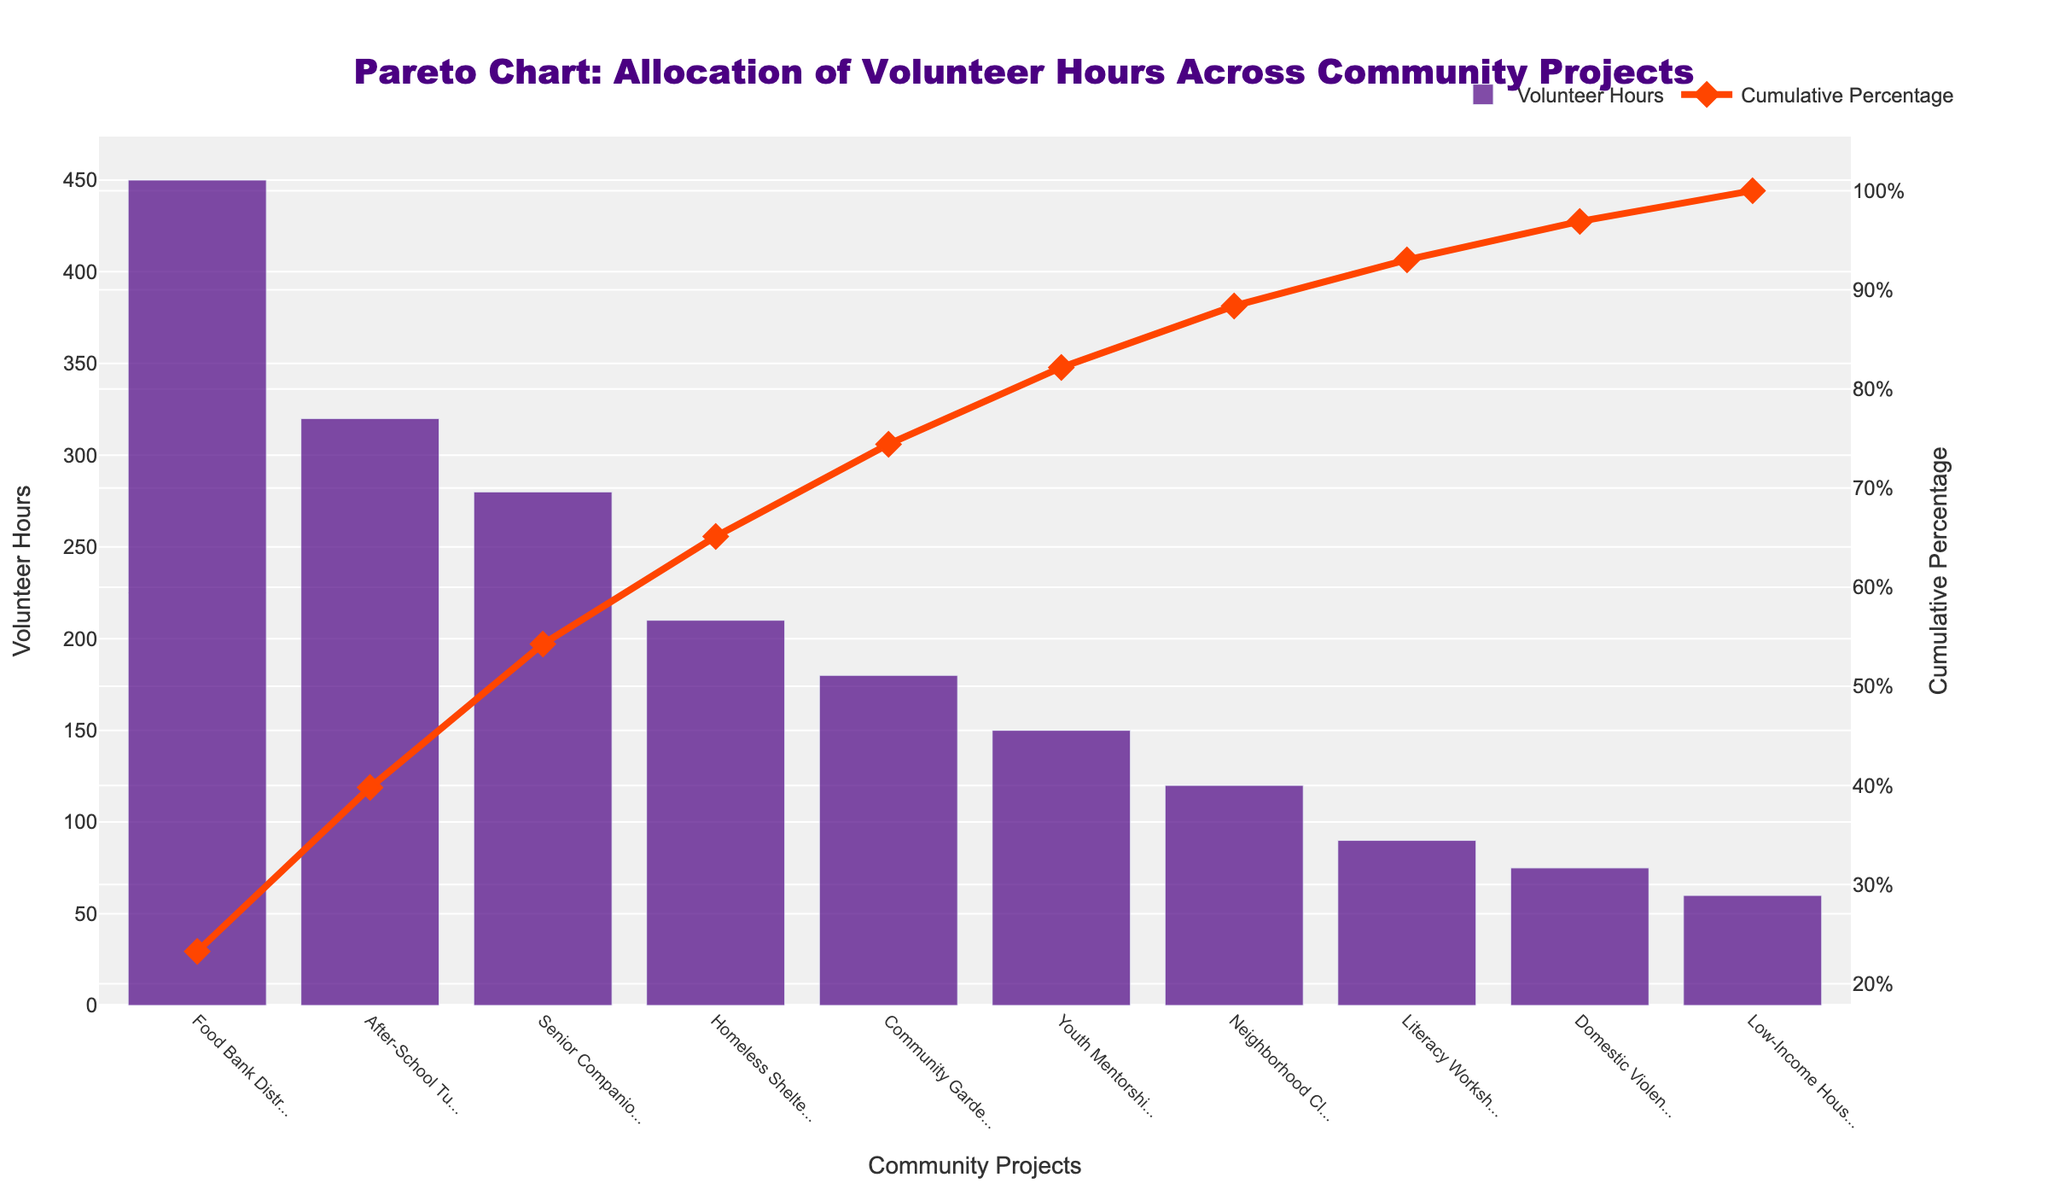What is the title of the figure? The title is usually positioned at the top of the chart and provides a brief description of what the chart represents. Here, it reads "Pareto Chart: Allocation of Volunteer Hours Across Community Projects".
Answer: Pareto Chart: Allocation of Volunteer Hours Across Community Projects How many community projects are represented in the chart? By counting the bars representing each project on the x-axis, you can determine the number of community projects displayed.
Answer: 10 Which project has the highest number of volunteer hours allocated? Look for the tallest bar on the chart. According to the figure, "Food Bank Distribution" has the tallest bar.
Answer: Food Bank Distribution What is the cumulative percentage associated with the "Homeless Shelter Support" project? Find the point on the cumulative percentage line that aligns with the "Homeless Shelter Support" project on the x-axis. It shows approximately 79%.
Answer: 79% What percentage of volunteer hours is represented by the first three projects combined? Combine the cumulative percentages of "Food Bank Distribution," "After-School Tutoring," and "Senior Companion Program". The percentages are approximately 43%, 71%, and 87% respectively. 87% minus 0% (start) gives 87%.
Answer: 87% Which project has fewer volunteer hours allocated: "Youth Mentorship" or "Neighborhood Clean-up"? Compare the heights of the bars for the two projects. "Youth Mentorship" has a taller bar than "Neighborhood Clean-up".
Answer: Neighborhood Clean-up Which project represents the 50% cumulative percentage mark? Find the project at which the cumulative percentage line crosses the 50% mark. This is at the "After-School Tutoring" point.
Answer: After-School Tutoring What is the cumulative percentage for the bottom three projects? Locate the cumulative percentages for the bottom three projects ("Literacy Workshop," "Domestic Violence Support Hotline," "Low-Income Housing Advocacy"), and subtract the percentage just before them, which sums to approximately 96%. Subtracting the percentage before "Literacy Workshop" (~87%) leaves about 9%.
Answer: 9% How does the cumulative percentage change after the "After-School Tutoring" project? Calculate the difference in cumulative percentage between "After-School Tutoring" (71%) and the next project, "Senior Companion Program" (87%), which equals 16%.
Answer: 16% What is the visual appearance of the volunteer hours bars in the figure? The bars are colored indigo (#4B0082), have a slight opacity (0.7), and are horizontal. This is evident from the consistent color and alignment in the figure.
Answer: Indigo, horizontal, semi-transparent 